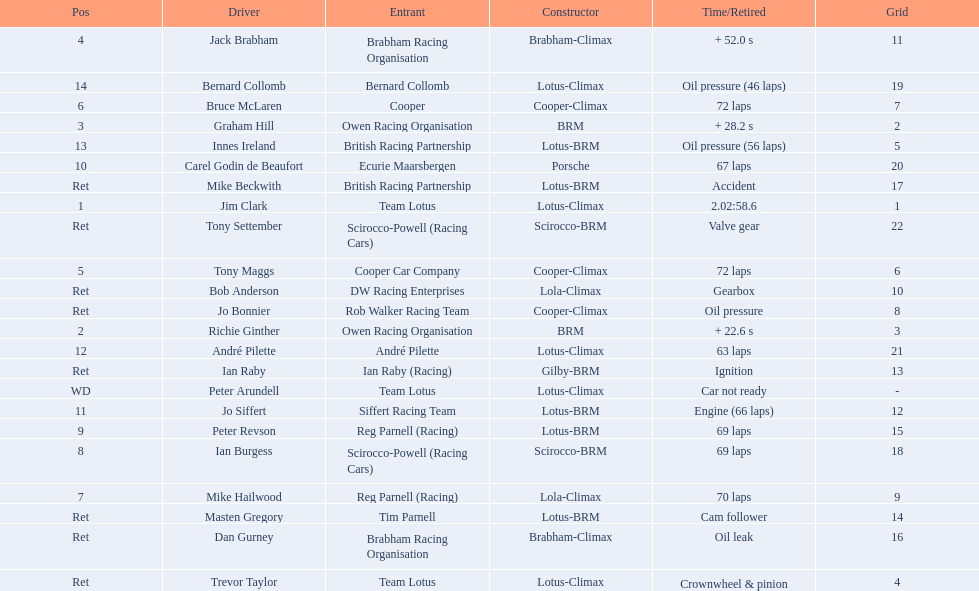Who are all the drivers? Jim Clark, Richie Ginther, Graham Hill, Jack Brabham, Tony Maggs, Bruce McLaren, Mike Hailwood, Ian Burgess, Peter Revson, Carel Godin de Beaufort, Jo Siffert, André Pilette, Innes Ireland, Bernard Collomb, Ian Raby, Dan Gurney, Mike Beckwith, Masten Gregory, Trevor Taylor, Jo Bonnier, Tony Settember, Bob Anderson, Peter Arundell. What were their positions? 1, 2, 3, 4, 5, 6, 7, 8, 9, 10, 11, 12, 13, 14, Ret, Ret, Ret, Ret, Ret, Ret, Ret, Ret, WD. I'm looking to parse the entire table for insights. Could you assist me with that? {'header': ['Pos', 'Driver', 'Entrant', 'Constructor', 'Time/Retired', 'Grid'], 'rows': [['4', 'Jack Brabham', 'Brabham Racing Organisation', 'Brabham-Climax', '+ 52.0 s', '11'], ['14', 'Bernard Collomb', 'Bernard Collomb', 'Lotus-Climax', 'Oil pressure (46 laps)', '19'], ['6', 'Bruce McLaren', 'Cooper', 'Cooper-Climax', '72 laps', '7'], ['3', 'Graham Hill', 'Owen Racing Organisation', 'BRM', '+ 28.2 s', '2'], ['13', 'Innes Ireland', 'British Racing Partnership', 'Lotus-BRM', 'Oil pressure (56 laps)', '5'], ['10', 'Carel Godin de Beaufort', 'Ecurie Maarsbergen', 'Porsche', '67 laps', '20'], ['Ret', 'Mike Beckwith', 'British Racing Partnership', 'Lotus-BRM', 'Accident', '17'], ['1', 'Jim Clark', 'Team Lotus', 'Lotus-Climax', '2.02:58.6', '1'], ['Ret', 'Tony Settember', 'Scirocco-Powell (Racing Cars)', 'Scirocco-BRM', 'Valve gear', '22'], ['5', 'Tony Maggs', 'Cooper Car Company', 'Cooper-Climax', '72 laps', '6'], ['Ret', 'Bob Anderson', 'DW Racing Enterprises', 'Lola-Climax', 'Gearbox', '10'], ['Ret', 'Jo Bonnier', 'Rob Walker Racing Team', 'Cooper-Climax', 'Oil pressure', '8'], ['2', 'Richie Ginther', 'Owen Racing Organisation', 'BRM', '+ 22.6 s', '3'], ['12', 'André Pilette', 'André Pilette', 'Lotus-Climax', '63 laps', '21'], ['Ret', 'Ian Raby', 'Ian Raby (Racing)', 'Gilby-BRM', 'Ignition', '13'], ['WD', 'Peter Arundell', 'Team Lotus', 'Lotus-Climax', 'Car not ready', '-'], ['11', 'Jo Siffert', 'Siffert Racing Team', 'Lotus-BRM', 'Engine (66 laps)', '12'], ['9', 'Peter Revson', 'Reg Parnell (Racing)', 'Lotus-BRM', '69 laps', '15'], ['8', 'Ian Burgess', 'Scirocco-Powell (Racing Cars)', 'Scirocco-BRM', '69 laps', '18'], ['7', 'Mike Hailwood', 'Reg Parnell (Racing)', 'Lola-Climax', '70 laps', '9'], ['Ret', 'Masten Gregory', 'Tim Parnell', 'Lotus-BRM', 'Cam follower', '14'], ['Ret', 'Dan Gurney', 'Brabham Racing Organisation', 'Brabham-Climax', 'Oil leak', '16'], ['Ret', 'Trevor Taylor', 'Team Lotus', 'Lotus-Climax', 'Crownwheel & pinion', '4']]} What are all the constructor names? Lotus-Climax, BRM, BRM, Brabham-Climax, Cooper-Climax, Cooper-Climax, Lola-Climax, Scirocco-BRM, Lotus-BRM, Porsche, Lotus-BRM, Lotus-Climax, Lotus-BRM, Lotus-Climax, Gilby-BRM, Brabham-Climax, Lotus-BRM, Lotus-BRM, Lotus-Climax, Cooper-Climax, Scirocco-BRM, Lola-Climax, Lotus-Climax. And which drivers drove a cooper-climax? Tony Maggs, Bruce McLaren. Between those tow, who was positioned higher? Tony Maggs. 